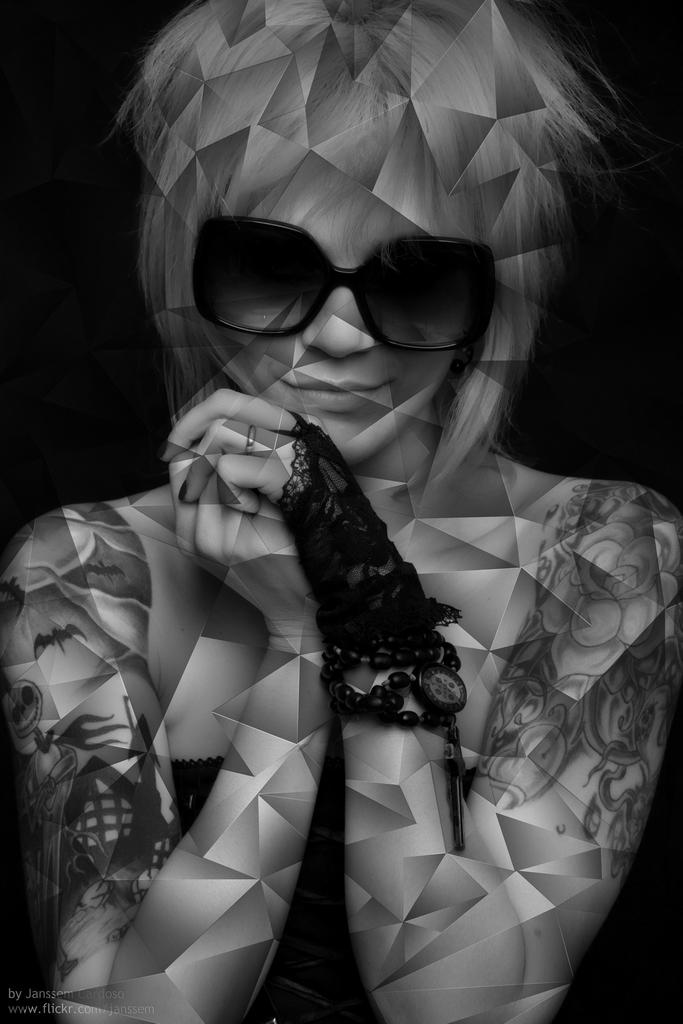What is the main subject of the image? The main subject of the image is a sketch of a girl. Can you describe the girl in the sketch? Unfortunately, the facts provided do not include any details about the girl's appearance or characteristics. What medium is used for the sketch? The facts provided do not specify the medium used for the sketch. How many yaks are present in the sketch? There are no yaks present in the sketch; it features a sketch of a girl. 